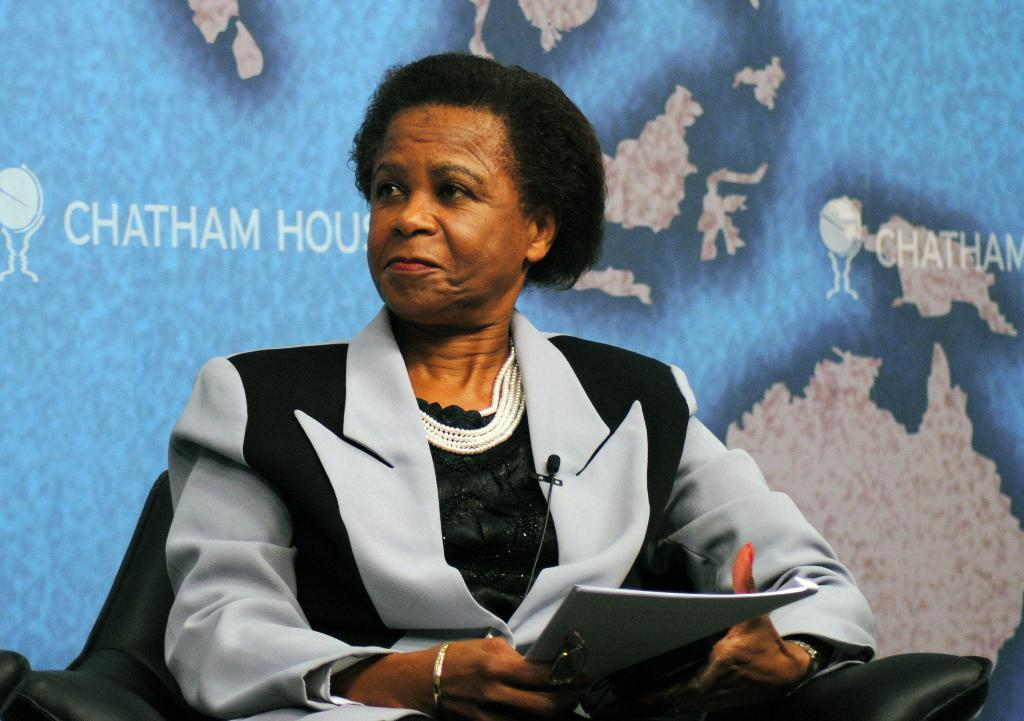Who is present in the image? There is a woman in the image. What is the woman doing in the image? The woman is seated on a chair and holding papers in her hands. What can be seen in the background of the image? There is a hoarding in the image, which has pictures and text on it. What is the size of the mine in the image? There is no mine present in the image; it features a woman seated on a chair holding papers and a hoarding in the background. 